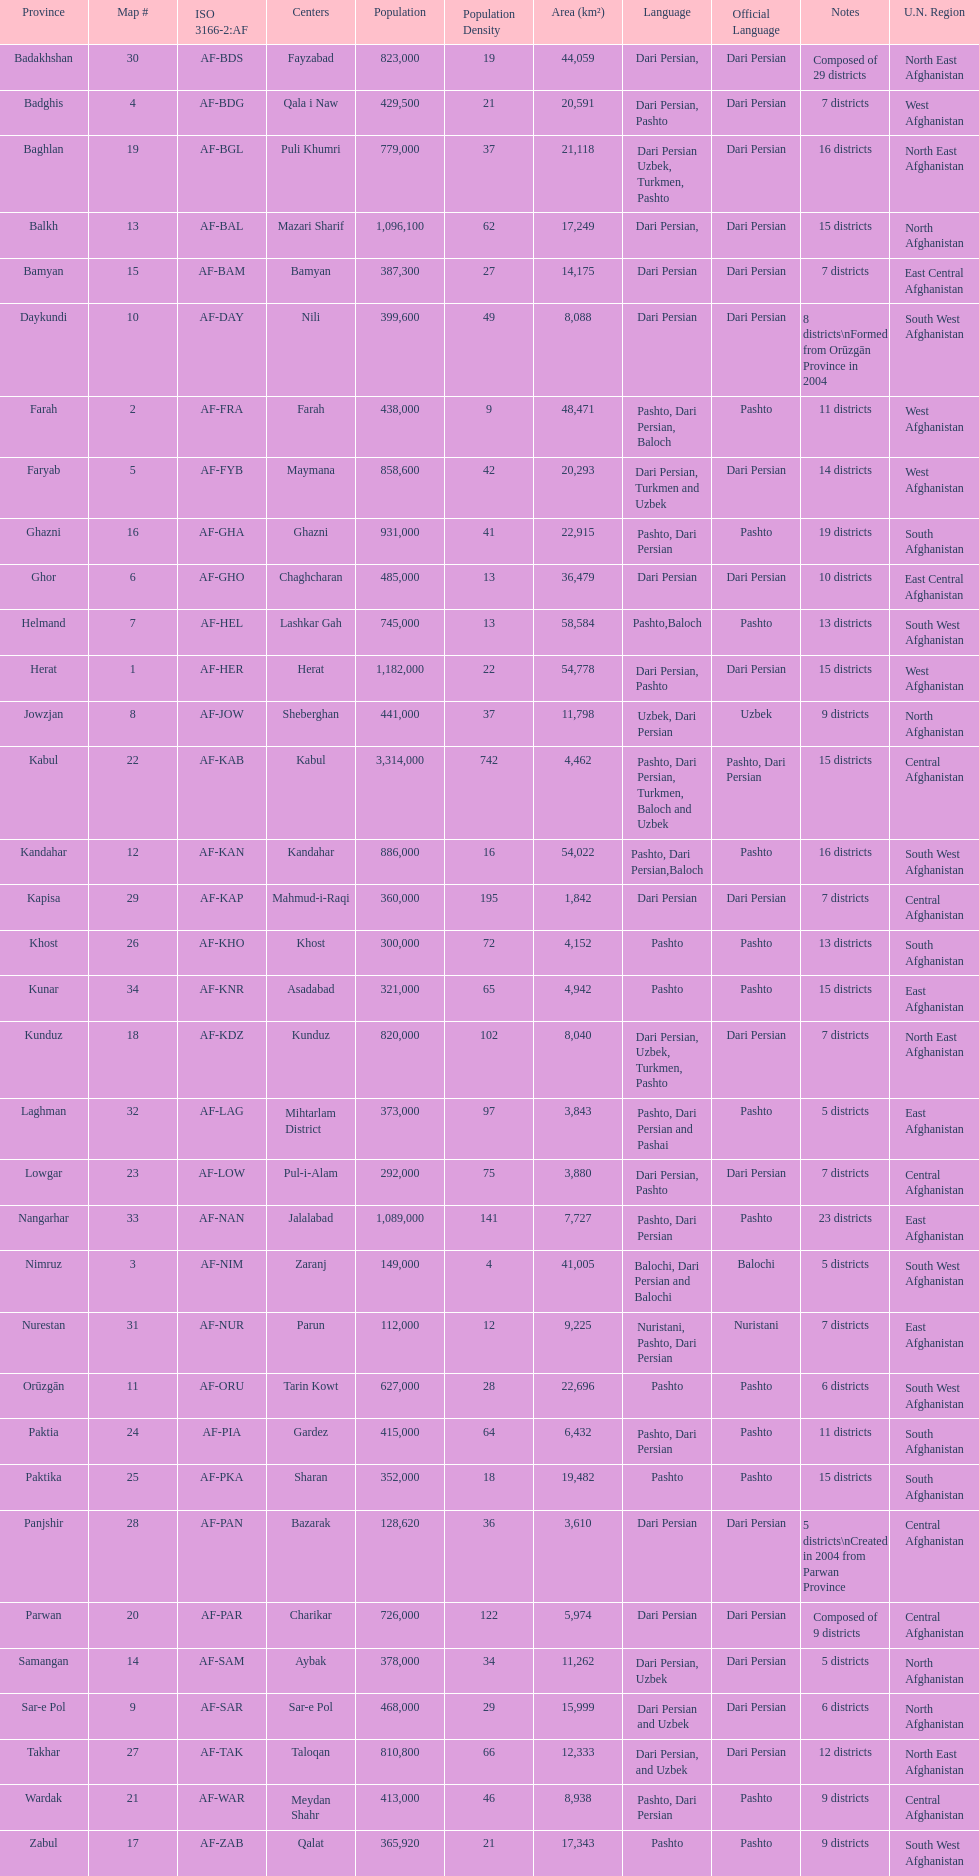What province in afghanistanhas the greatest population? Kabul. 